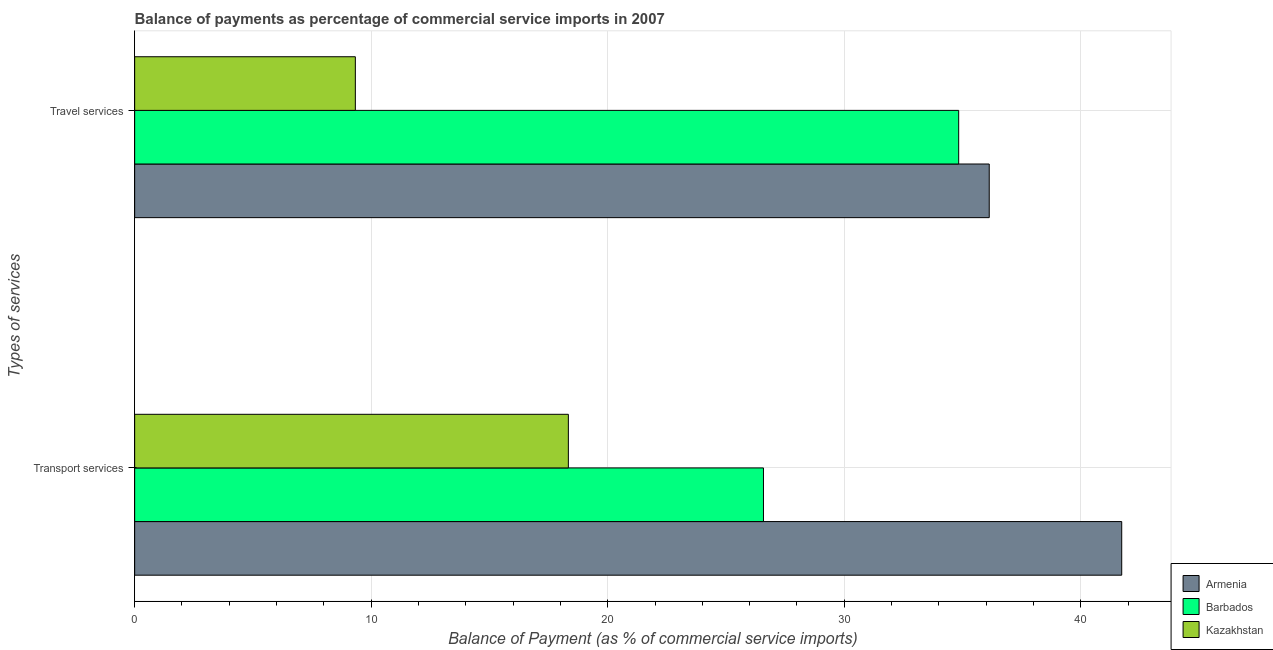How many groups of bars are there?
Provide a short and direct response. 2. Are the number of bars per tick equal to the number of legend labels?
Your answer should be compact. Yes. How many bars are there on the 1st tick from the top?
Offer a terse response. 3. How many bars are there on the 1st tick from the bottom?
Ensure brevity in your answer.  3. What is the label of the 1st group of bars from the top?
Your answer should be very brief. Travel services. What is the balance of payments of travel services in Armenia?
Offer a terse response. 36.13. Across all countries, what is the maximum balance of payments of travel services?
Your response must be concise. 36.13. Across all countries, what is the minimum balance of payments of transport services?
Make the answer very short. 18.34. In which country was the balance of payments of travel services maximum?
Provide a succinct answer. Armenia. In which country was the balance of payments of transport services minimum?
Provide a succinct answer. Kazakhstan. What is the total balance of payments of travel services in the graph?
Provide a short and direct response. 80.3. What is the difference between the balance of payments of travel services in Barbados and that in Armenia?
Give a very brief answer. -1.29. What is the difference between the balance of payments of travel services in Barbados and the balance of payments of transport services in Kazakhstan?
Offer a terse response. 16.5. What is the average balance of payments of transport services per country?
Provide a succinct answer. 28.88. What is the difference between the balance of payments of transport services and balance of payments of travel services in Barbados?
Keep it short and to the point. -8.25. What is the ratio of the balance of payments of transport services in Kazakhstan to that in Armenia?
Your response must be concise. 0.44. What does the 1st bar from the top in Transport services represents?
Keep it short and to the point. Kazakhstan. What does the 3rd bar from the bottom in Transport services represents?
Provide a short and direct response. Kazakhstan. How many bars are there?
Your answer should be very brief. 6. Are the values on the major ticks of X-axis written in scientific E-notation?
Your answer should be compact. No. Does the graph contain any zero values?
Provide a short and direct response. No. Where does the legend appear in the graph?
Provide a succinct answer. Bottom right. How many legend labels are there?
Your answer should be compact. 3. What is the title of the graph?
Your answer should be very brief. Balance of payments as percentage of commercial service imports in 2007. Does "New Zealand" appear as one of the legend labels in the graph?
Offer a terse response. No. What is the label or title of the X-axis?
Offer a very short reply. Balance of Payment (as % of commercial service imports). What is the label or title of the Y-axis?
Your response must be concise. Types of services. What is the Balance of Payment (as % of commercial service imports) of Armenia in Transport services?
Your response must be concise. 41.73. What is the Balance of Payment (as % of commercial service imports) of Barbados in Transport services?
Offer a very short reply. 26.58. What is the Balance of Payment (as % of commercial service imports) of Kazakhstan in Transport services?
Offer a very short reply. 18.34. What is the Balance of Payment (as % of commercial service imports) in Armenia in Travel services?
Give a very brief answer. 36.13. What is the Balance of Payment (as % of commercial service imports) of Barbados in Travel services?
Give a very brief answer. 34.84. What is the Balance of Payment (as % of commercial service imports) of Kazakhstan in Travel services?
Provide a short and direct response. 9.33. Across all Types of services, what is the maximum Balance of Payment (as % of commercial service imports) in Armenia?
Your answer should be compact. 41.73. Across all Types of services, what is the maximum Balance of Payment (as % of commercial service imports) in Barbados?
Provide a succinct answer. 34.84. Across all Types of services, what is the maximum Balance of Payment (as % of commercial service imports) of Kazakhstan?
Ensure brevity in your answer.  18.34. Across all Types of services, what is the minimum Balance of Payment (as % of commercial service imports) of Armenia?
Keep it short and to the point. 36.13. Across all Types of services, what is the minimum Balance of Payment (as % of commercial service imports) of Barbados?
Ensure brevity in your answer.  26.58. Across all Types of services, what is the minimum Balance of Payment (as % of commercial service imports) in Kazakhstan?
Your answer should be very brief. 9.33. What is the total Balance of Payment (as % of commercial service imports) of Armenia in the graph?
Make the answer very short. 77.86. What is the total Balance of Payment (as % of commercial service imports) of Barbados in the graph?
Ensure brevity in your answer.  61.42. What is the total Balance of Payment (as % of commercial service imports) of Kazakhstan in the graph?
Make the answer very short. 27.67. What is the difference between the Balance of Payment (as % of commercial service imports) in Armenia in Transport services and that in Travel services?
Your response must be concise. 5.6. What is the difference between the Balance of Payment (as % of commercial service imports) of Barbados in Transport services and that in Travel services?
Provide a short and direct response. -8.25. What is the difference between the Balance of Payment (as % of commercial service imports) in Kazakhstan in Transport services and that in Travel services?
Offer a very short reply. 9.01. What is the difference between the Balance of Payment (as % of commercial service imports) in Armenia in Transport services and the Balance of Payment (as % of commercial service imports) in Barbados in Travel services?
Ensure brevity in your answer.  6.89. What is the difference between the Balance of Payment (as % of commercial service imports) of Armenia in Transport services and the Balance of Payment (as % of commercial service imports) of Kazakhstan in Travel services?
Offer a terse response. 32.4. What is the difference between the Balance of Payment (as % of commercial service imports) in Barbados in Transport services and the Balance of Payment (as % of commercial service imports) in Kazakhstan in Travel services?
Ensure brevity in your answer.  17.25. What is the average Balance of Payment (as % of commercial service imports) of Armenia per Types of services?
Your answer should be very brief. 38.93. What is the average Balance of Payment (as % of commercial service imports) of Barbados per Types of services?
Your answer should be compact. 30.71. What is the average Balance of Payment (as % of commercial service imports) of Kazakhstan per Types of services?
Keep it short and to the point. 13.83. What is the difference between the Balance of Payment (as % of commercial service imports) of Armenia and Balance of Payment (as % of commercial service imports) of Barbados in Transport services?
Your answer should be compact. 15.15. What is the difference between the Balance of Payment (as % of commercial service imports) of Armenia and Balance of Payment (as % of commercial service imports) of Kazakhstan in Transport services?
Make the answer very short. 23.39. What is the difference between the Balance of Payment (as % of commercial service imports) of Barbados and Balance of Payment (as % of commercial service imports) of Kazakhstan in Transport services?
Offer a very short reply. 8.25. What is the difference between the Balance of Payment (as % of commercial service imports) in Armenia and Balance of Payment (as % of commercial service imports) in Barbados in Travel services?
Ensure brevity in your answer.  1.29. What is the difference between the Balance of Payment (as % of commercial service imports) in Armenia and Balance of Payment (as % of commercial service imports) in Kazakhstan in Travel services?
Ensure brevity in your answer.  26.8. What is the difference between the Balance of Payment (as % of commercial service imports) in Barbados and Balance of Payment (as % of commercial service imports) in Kazakhstan in Travel services?
Your response must be concise. 25.51. What is the ratio of the Balance of Payment (as % of commercial service imports) of Armenia in Transport services to that in Travel services?
Your answer should be compact. 1.16. What is the ratio of the Balance of Payment (as % of commercial service imports) of Barbados in Transport services to that in Travel services?
Offer a very short reply. 0.76. What is the ratio of the Balance of Payment (as % of commercial service imports) in Kazakhstan in Transport services to that in Travel services?
Keep it short and to the point. 1.97. What is the difference between the highest and the second highest Balance of Payment (as % of commercial service imports) in Armenia?
Your response must be concise. 5.6. What is the difference between the highest and the second highest Balance of Payment (as % of commercial service imports) in Barbados?
Offer a terse response. 8.25. What is the difference between the highest and the second highest Balance of Payment (as % of commercial service imports) in Kazakhstan?
Your answer should be compact. 9.01. What is the difference between the highest and the lowest Balance of Payment (as % of commercial service imports) of Armenia?
Give a very brief answer. 5.6. What is the difference between the highest and the lowest Balance of Payment (as % of commercial service imports) of Barbados?
Ensure brevity in your answer.  8.25. What is the difference between the highest and the lowest Balance of Payment (as % of commercial service imports) of Kazakhstan?
Ensure brevity in your answer.  9.01. 